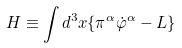Convert formula to latex. <formula><loc_0><loc_0><loc_500><loc_500>H \equiv \int d ^ { 3 } x \{ \pi ^ { \alpha } \dot { \varphi } ^ { \alpha } - L \}</formula> 